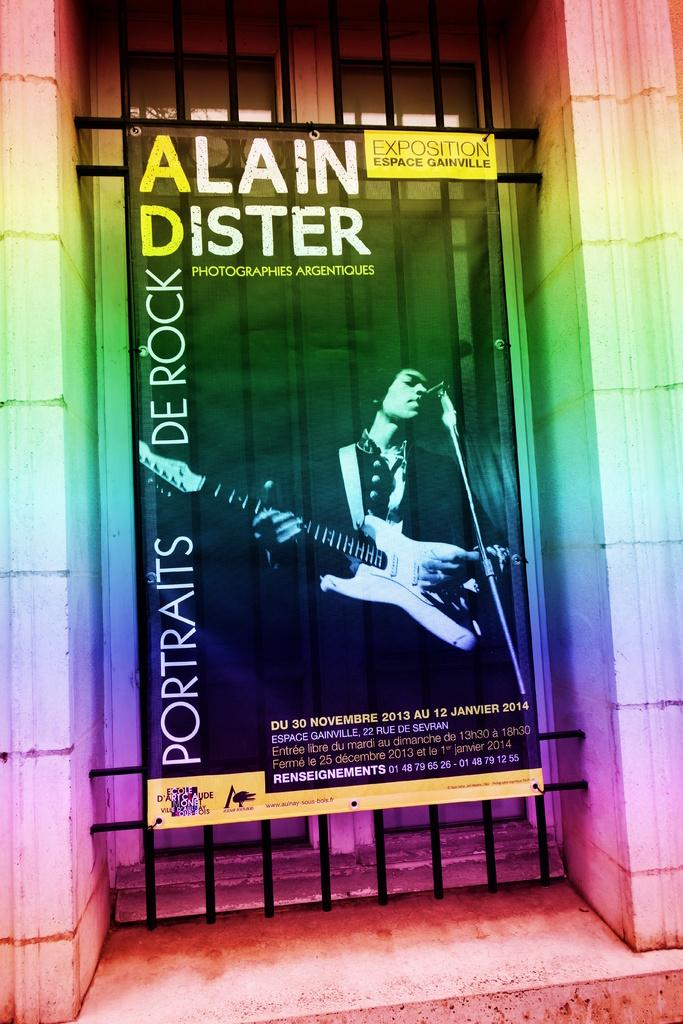What is present in the image that is related to advertising or displaying information? There is a poster in the image. How is the poster being supported or displayed? The poster is attached to a metal rod frame. Where is the cow located in the image? There is no cow present in the image. What type of store is featured in the image? There is no store present in the image. 